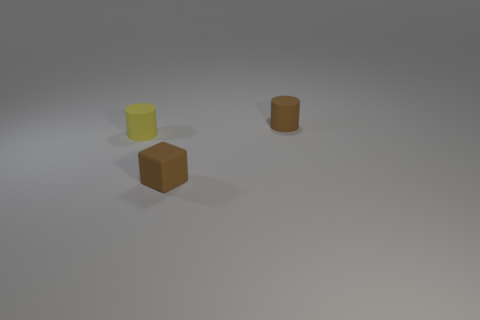Subtract all cylinders. How many objects are left? 1 Add 3 big gray metal balls. How many objects exist? 6 Subtract 0 gray cylinders. How many objects are left? 3 Subtract all purple cylinders. Subtract all cyan cubes. How many cylinders are left? 2 Subtract all purple balls. How many yellow cylinders are left? 1 Subtract all tiny yellow matte things. Subtract all large blue shiny things. How many objects are left? 2 Add 1 brown cubes. How many brown cubes are left? 2 Add 2 tiny brown cylinders. How many tiny brown cylinders exist? 3 